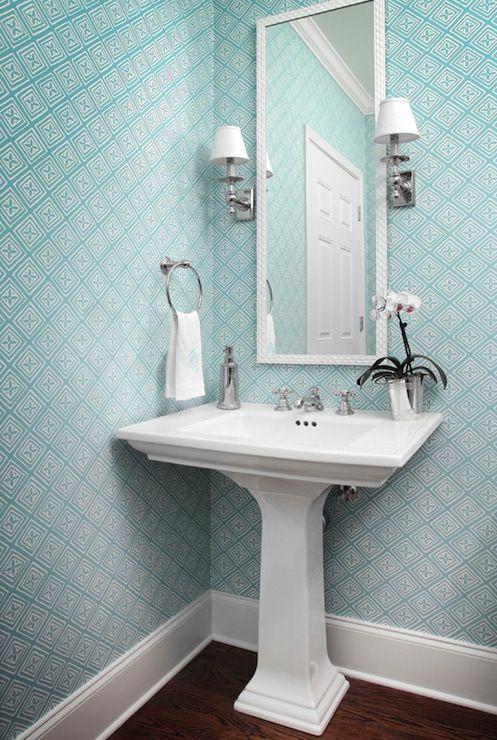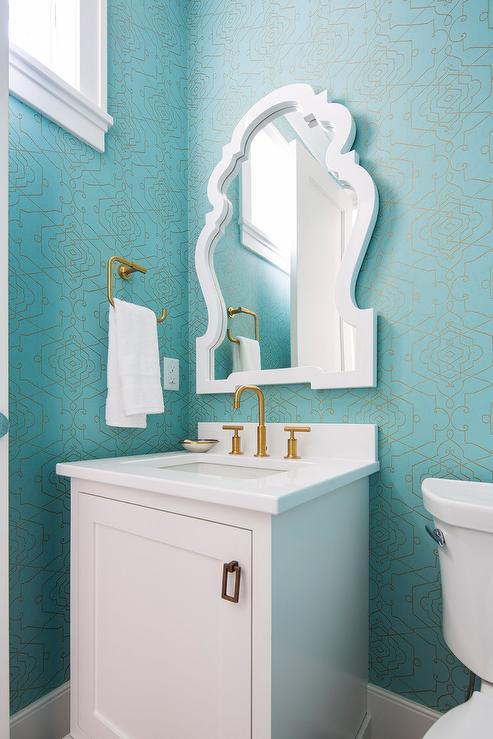The first image is the image on the left, the second image is the image on the right. Assess this claim about the two images: "One bathroom features a rectangular mirror over a pedestal sink with a flower in a vase on it, and the other image shows a sink with a box-shaped vanity and a non-square mirror.". Correct or not? Answer yes or no. Yes. The first image is the image on the left, the second image is the image on the right. Given the left and right images, does the statement "One of the images features a sink with a cabinet underneath." hold true? Answer yes or no. Yes. 